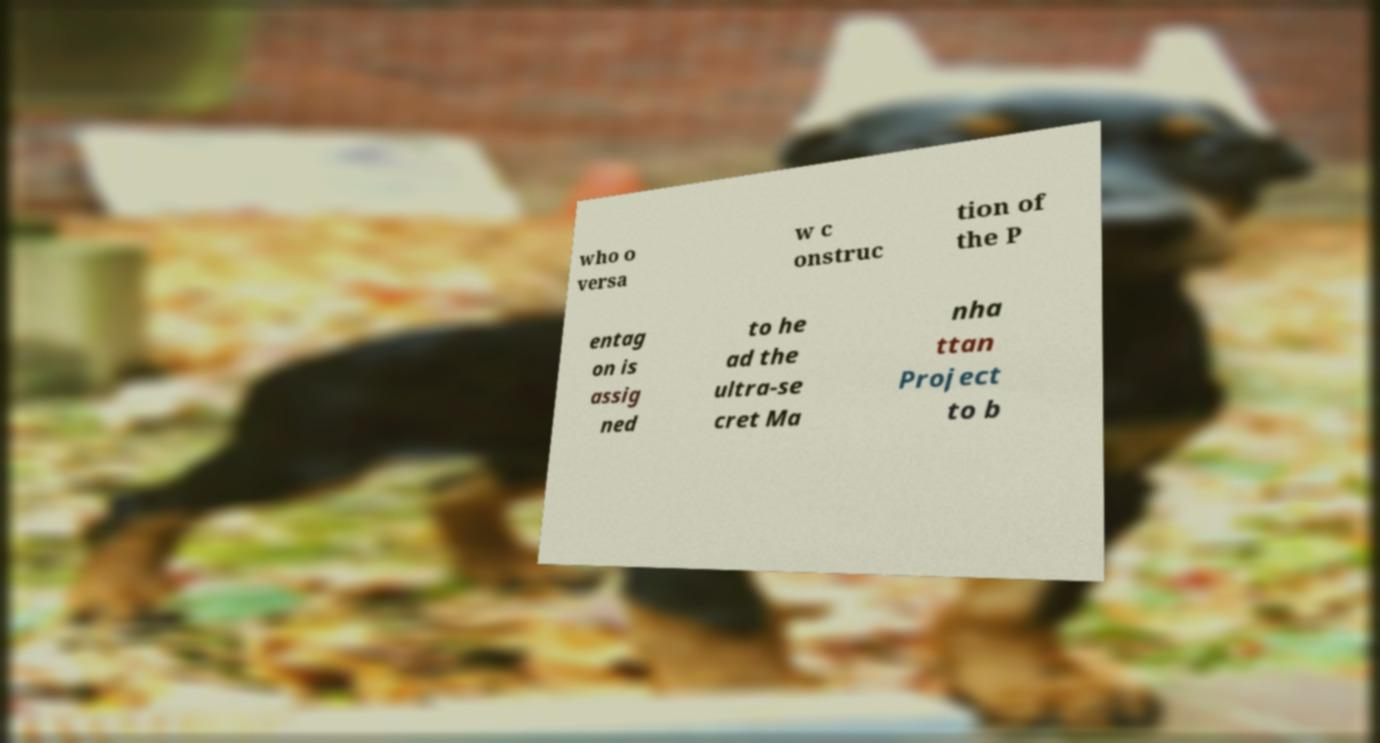I need the written content from this picture converted into text. Can you do that? who o versa w c onstruc tion of the P entag on is assig ned to he ad the ultra-se cret Ma nha ttan Project to b 